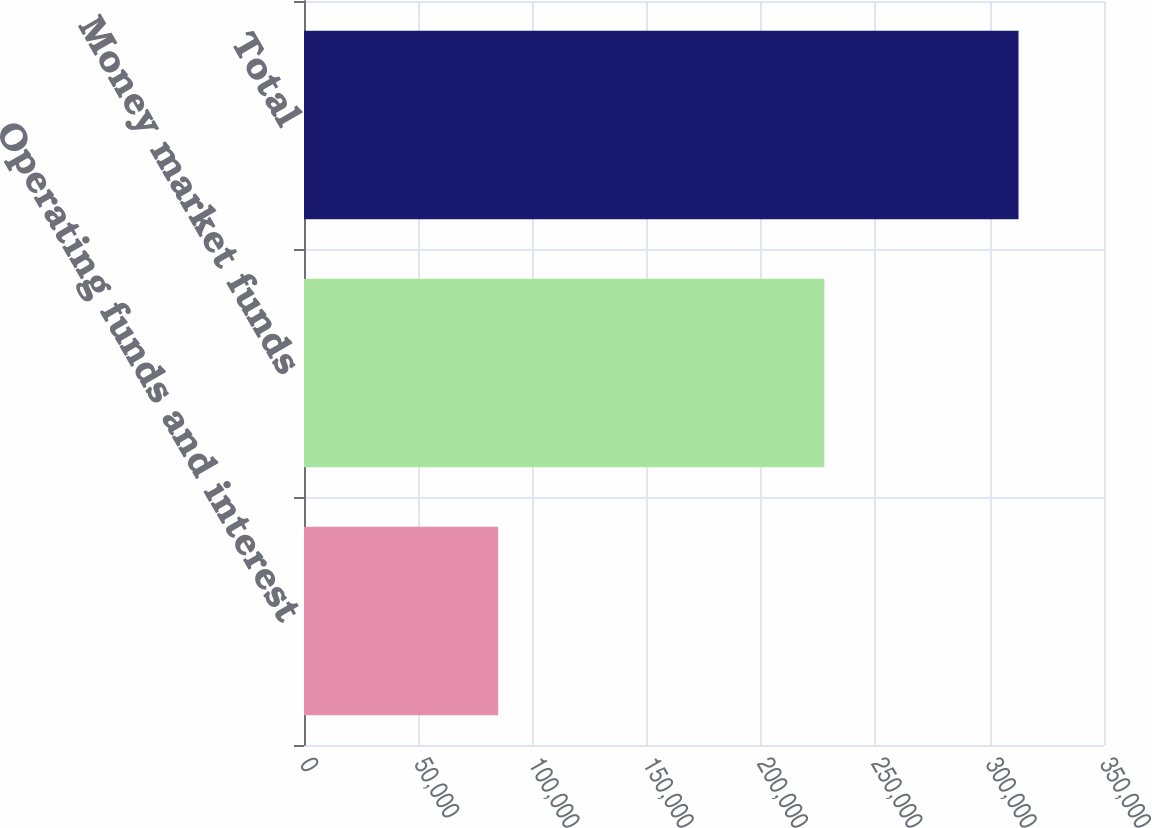Convert chart. <chart><loc_0><loc_0><loc_500><loc_500><bar_chart><fcel>Operating funds and interest<fcel>Money market funds<fcel>Total<nl><fcel>84943<fcel>227663<fcel>312606<nl></chart> 